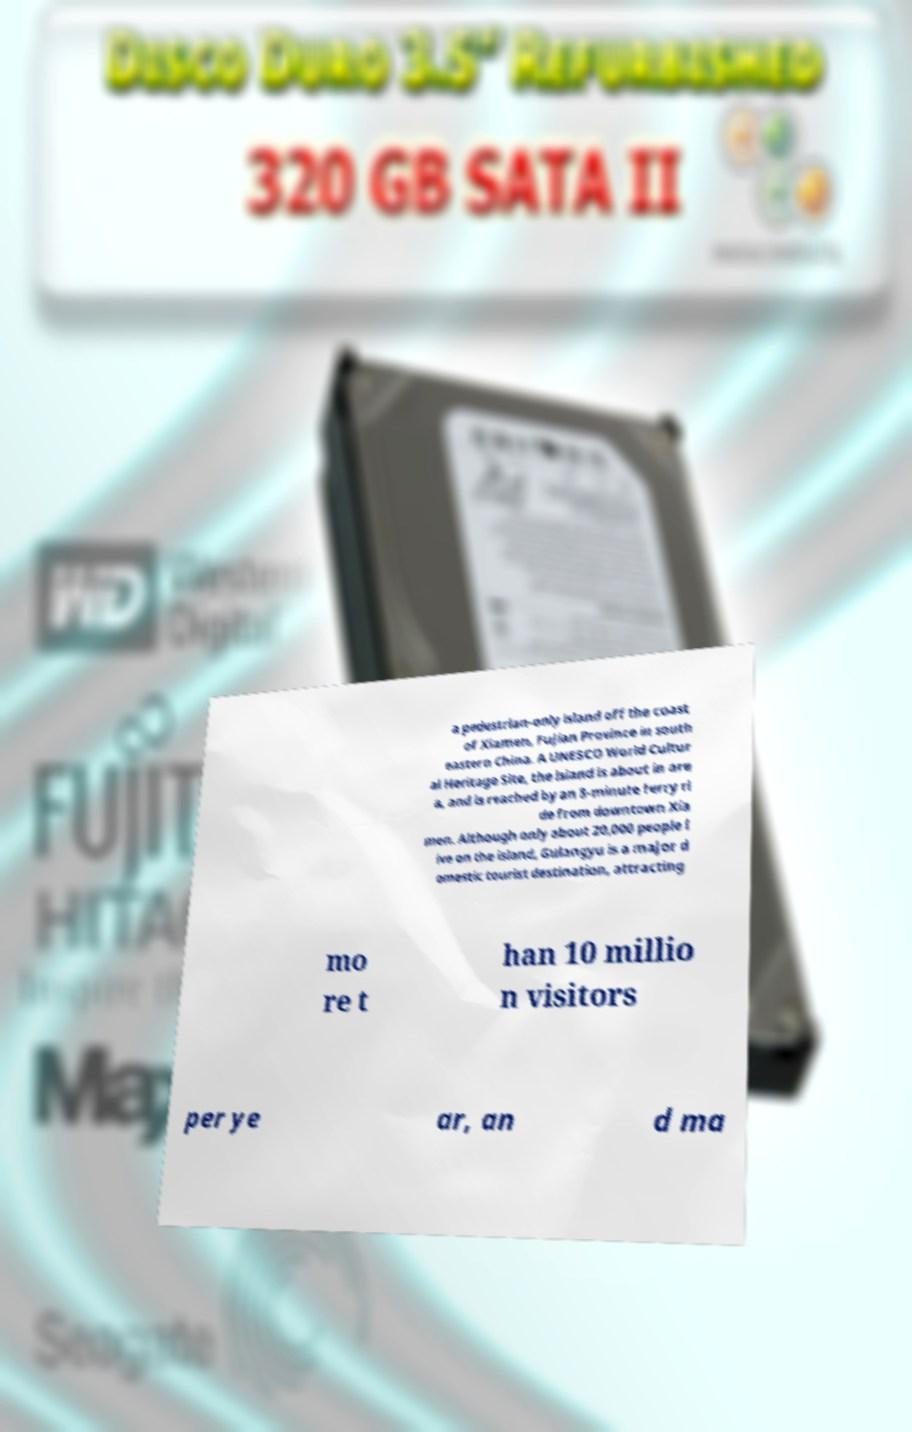Could you assist in decoding the text presented in this image and type it out clearly? a pedestrian-only island off the coast of Xiamen, Fujian Province in south eastern China. A UNESCO World Cultur al Heritage Site, the island is about in are a, and is reached by an 8-minute ferry ri de from downtown Xia men. Although only about 20,000 people l ive on the island, Gulangyu is a major d omestic tourist destination, attracting mo re t han 10 millio n visitors per ye ar, an d ma 